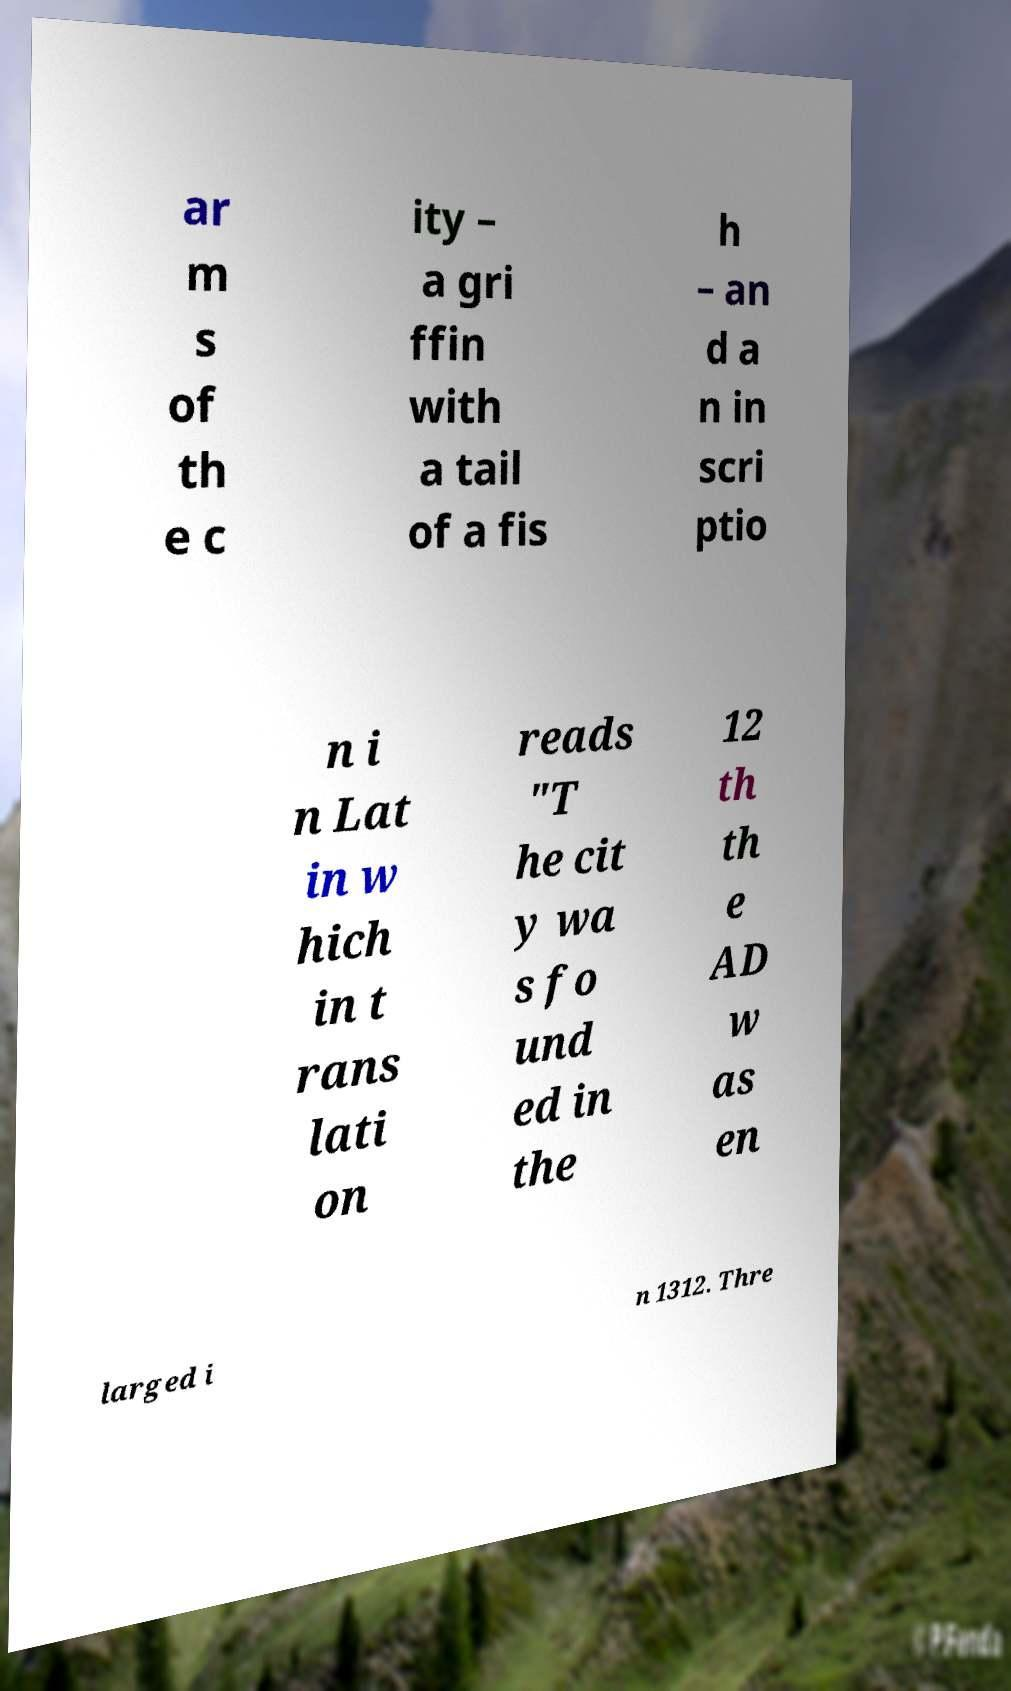Could you extract and type out the text from this image? ar m s of th e c ity – a gri ffin with a tail of a fis h – an d a n in scri ptio n i n Lat in w hich in t rans lati on reads "T he cit y wa s fo und ed in the 12 th th e AD w as en larged i n 1312. Thre 